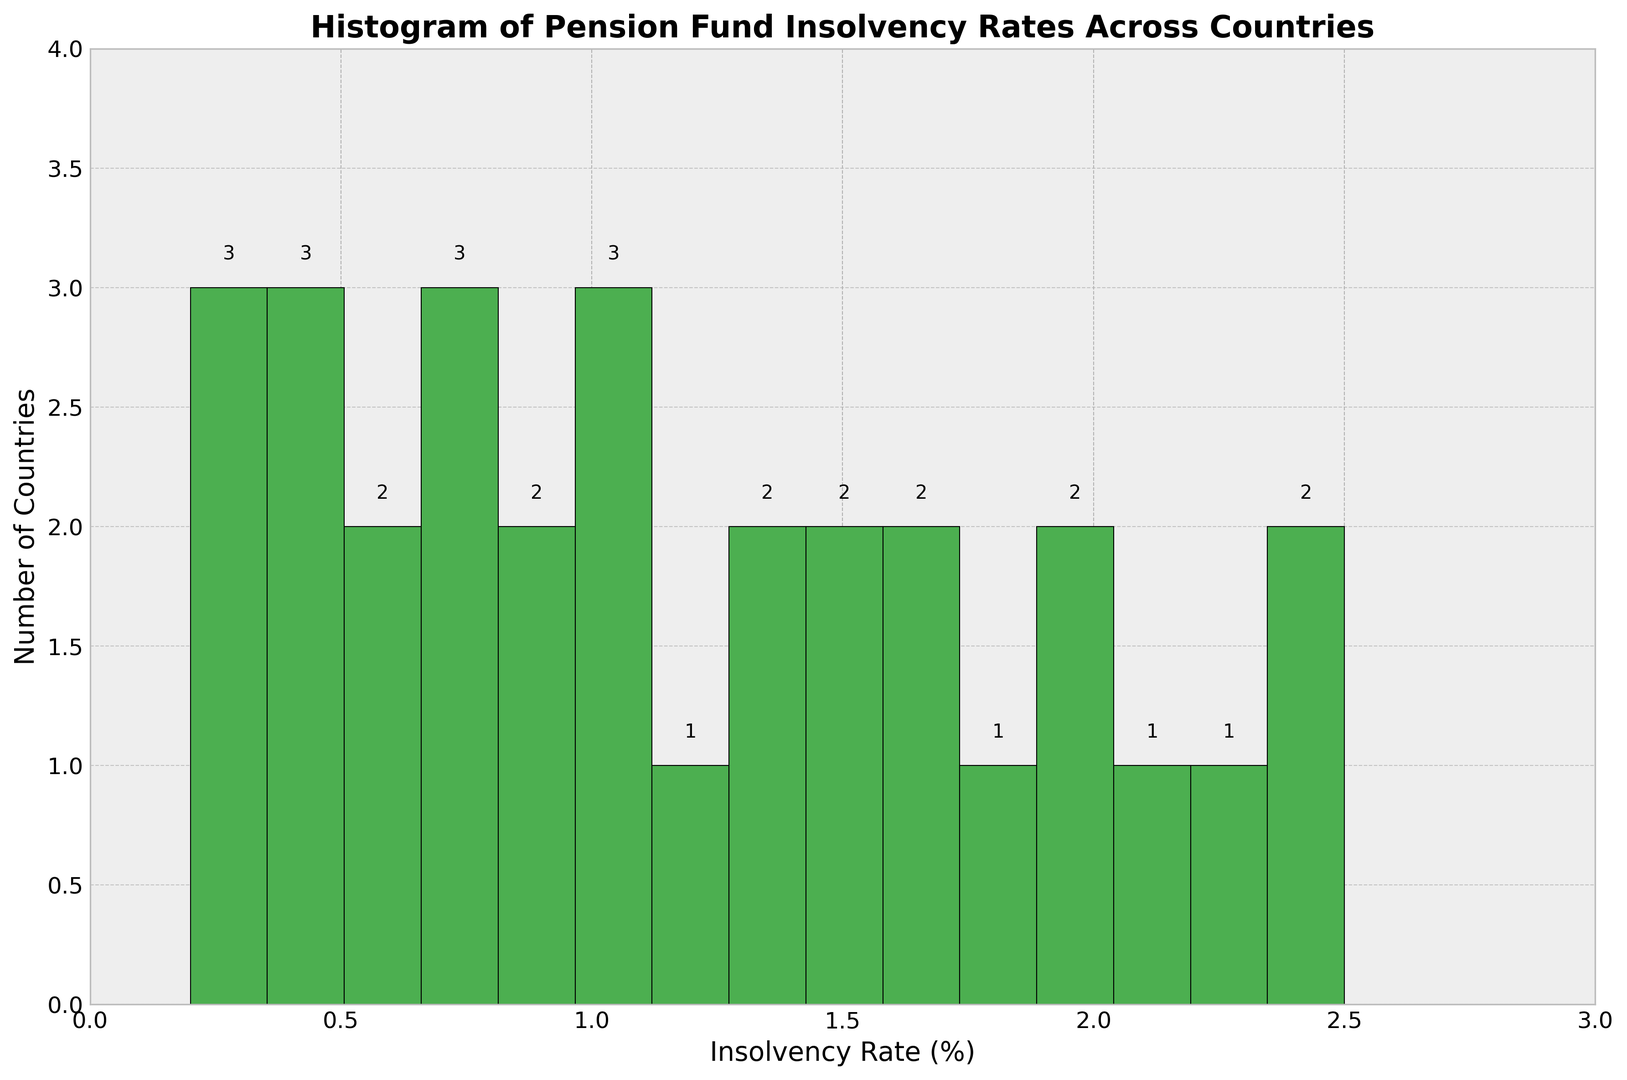Which country has the highest pension fund insolvency rate? First, examine the histogram and locate the highest bar. Then, find the corresponding insolvency rate on the x-axis and identify the country with that rate from the dataset.
Answer: Greece How many countries have an insolvency rate between 1.0% and 2.0%? Look at the bars in the histogram corresponding to the insolvency rate range of 1.0% to 2.0%, and count the number of bars within this range.
Answer: 10 What is the most common insolvency rate range among the countries? Identify the tallest bar in the histogram and note the insolvency rate range it represents.
Answer: 0.5% to 0.7% Compare the number of countries with insolvency rates under 1.0% versus those with rates of 1.0% and above. Count the number of bars representing insolvency rates below 1.0%, and compare this sum to the count of bars representing rates of 1.0% and higher.
Answer: Under 1.0%: 10, 1.0% and above: 15 What is the overall range of pension fund insolvency rates across all countries? Identify the minimum and maximum insolvency rates shown on the x-axis of the histogram.
Answer: 0.2% to 2.5% Which country has an insolvency rate closest to the median of the data? There are 25 data points; the median is the 13th value when sorted. Arrange all insolvency rates in ascending order and find the middle value, then identify the corresponding country from the dataset.
Answer: Spain How many countries have pension fund insolvency rates below the median rate? First, determine the median insolvency rate as the 13th value when sorted. Then, count the number of countries with rates below this value.
Answer: 12 Identify the color used to represent the bars in the histogram. Look at the visual attributes of the bars in the histogram to determine the color.
Answer: Green Which countries have insolvency rates higher than 2.0%? Check the bars representing insolvency rates above 2.0% and identify the corresponding countries from the dataset.
Answer: Greece, Mexico, Brazil, South Africa How many countries have insolvency rates exactly equal to 1.5%? Locate the bar corresponding to the insolvency rate of 1.5% in the histogram and read the height of this bar to determine the number of countries.
Answer: 2 